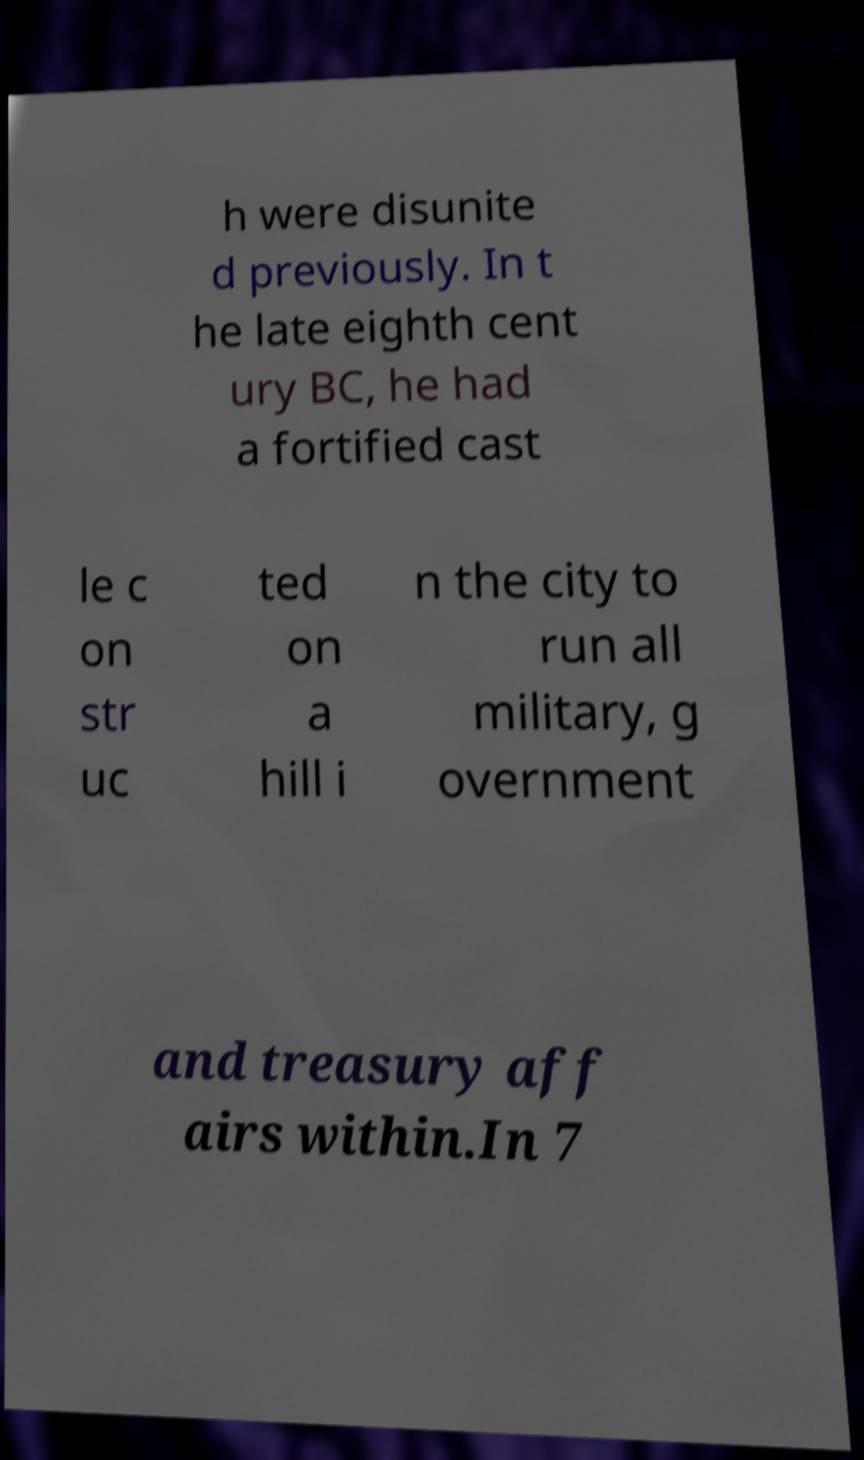Please read and relay the text visible in this image. What does it say? h were disunite d previously. In t he late eighth cent ury BC, he had a fortified cast le c on str uc ted on a hill i n the city to run all military, g overnment and treasury aff airs within.In 7 